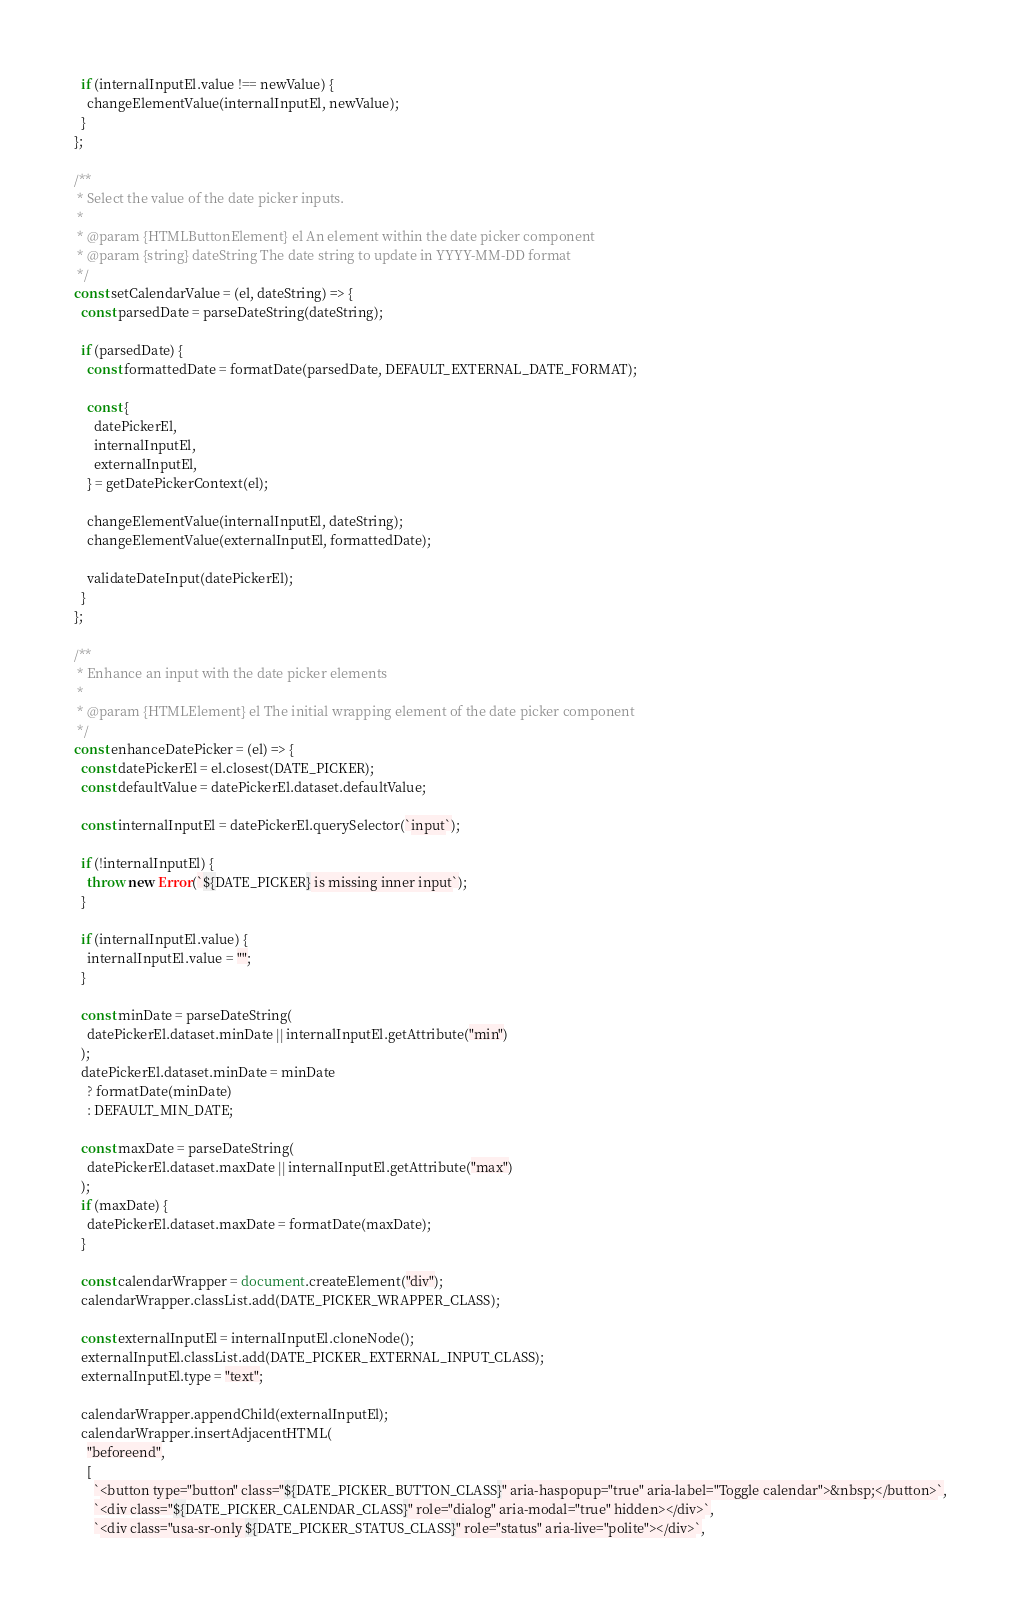Convert code to text. <code><loc_0><loc_0><loc_500><loc_500><_JavaScript_>  if (internalInputEl.value !== newValue) {
    changeElementValue(internalInputEl, newValue);
  }
};

/**
 * Select the value of the date picker inputs.
 *
 * @param {HTMLButtonElement} el An element within the date picker component
 * @param {string} dateString The date string to update in YYYY-MM-DD format
 */
const setCalendarValue = (el, dateString) => {
  const parsedDate = parseDateString(dateString);

  if (parsedDate) {
    const formattedDate = formatDate(parsedDate, DEFAULT_EXTERNAL_DATE_FORMAT);

    const {
      datePickerEl,
      internalInputEl,
      externalInputEl,
    } = getDatePickerContext(el);

    changeElementValue(internalInputEl, dateString);
    changeElementValue(externalInputEl, formattedDate);

    validateDateInput(datePickerEl);
  }
};

/**
 * Enhance an input with the date picker elements
 *
 * @param {HTMLElement} el The initial wrapping element of the date picker component
 */
const enhanceDatePicker = (el) => {
  const datePickerEl = el.closest(DATE_PICKER);
  const defaultValue = datePickerEl.dataset.defaultValue;

  const internalInputEl = datePickerEl.querySelector(`input`);

  if (!internalInputEl) {
    throw new Error(`${DATE_PICKER} is missing inner input`);
  }

  if (internalInputEl.value) {
    internalInputEl.value = "";
  }

  const minDate = parseDateString(
    datePickerEl.dataset.minDate || internalInputEl.getAttribute("min")
  );
  datePickerEl.dataset.minDate = minDate
    ? formatDate(minDate)
    : DEFAULT_MIN_DATE;

  const maxDate = parseDateString(
    datePickerEl.dataset.maxDate || internalInputEl.getAttribute("max")
  );
  if (maxDate) {
    datePickerEl.dataset.maxDate = formatDate(maxDate);
  }

  const calendarWrapper = document.createElement("div");
  calendarWrapper.classList.add(DATE_PICKER_WRAPPER_CLASS);

  const externalInputEl = internalInputEl.cloneNode();
  externalInputEl.classList.add(DATE_PICKER_EXTERNAL_INPUT_CLASS);
  externalInputEl.type = "text";

  calendarWrapper.appendChild(externalInputEl);
  calendarWrapper.insertAdjacentHTML(
    "beforeend",
    [
      `<button type="button" class="${DATE_PICKER_BUTTON_CLASS}" aria-haspopup="true" aria-label="Toggle calendar">&nbsp;</button>`,
      `<div class="${DATE_PICKER_CALENDAR_CLASS}" role="dialog" aria-modal="true" hidden></div>`,
      `<div class="usa-sr-only ${DATE_PICKER_STATUS_CLASS}" role="status" aria-live="polite"></div>`,</code> 